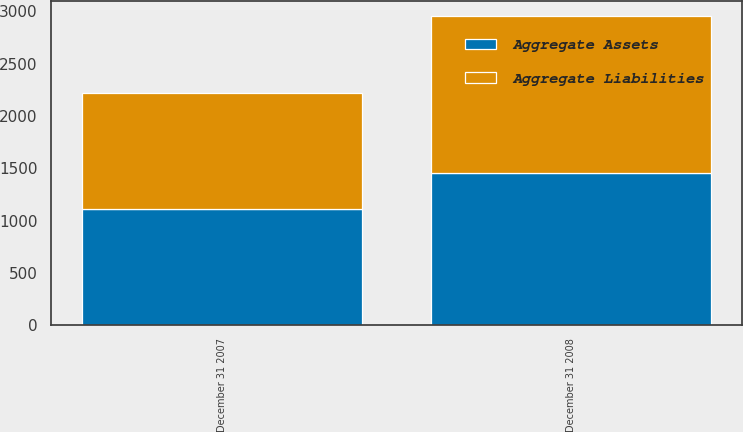Convert chart to OTSL. <chart><loc_0><loc_0><loc_500><loc_500><stacked_bar_chart><ecel><fcel>December 31 2008<fcel>December 31 2007<nl><fcel>Aggregate Liabilities<fcel>1499<fcel>1108<nl><fcel>Aggregate Assets<fcel>1455<fcel>1108<nl></chart> 